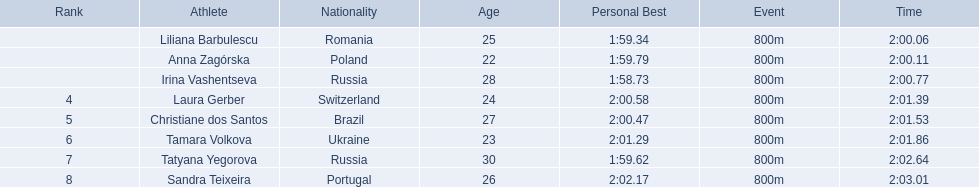Who were all of the athletes? Liliana Barbulescu, Anna Zagórska, Irina Vashentseva, Laura Gerber, Christiane dos Santos, Tamara Volkova, Tatyana Yegorova, Sandra Teixeira. What were their finishing times? 2:00.06, 2:00.11, 2:00.77, 2:01.39, 2:01.53, 2:01.86, 2:02.64, 2:03.01. Which athlete finished earliest? Liliana Barbulescu. 